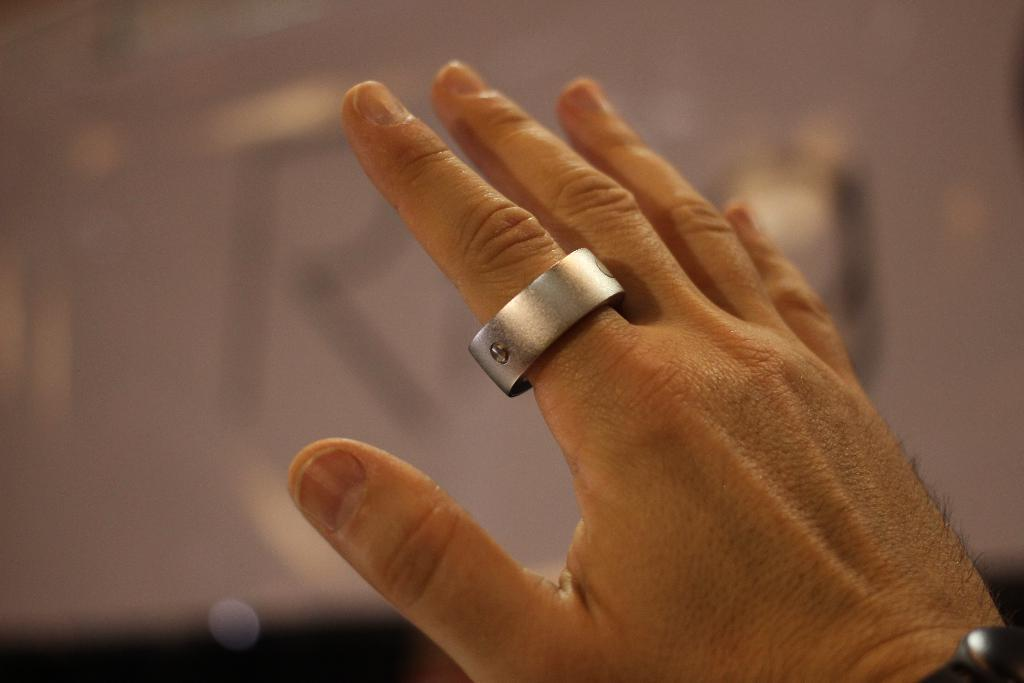What part of a person's body is visible in the image? There is a person's hand in the image. What type of accessory is on the hand? There is a ring on the hand. Can you describe the background of the image? The background of the image is blurred. Where is the nest located in the image? There is no nest present in the image. What type of division is being performed by the hand in the image? The hand in the image is not performing any division; it is simply holding a ring. 